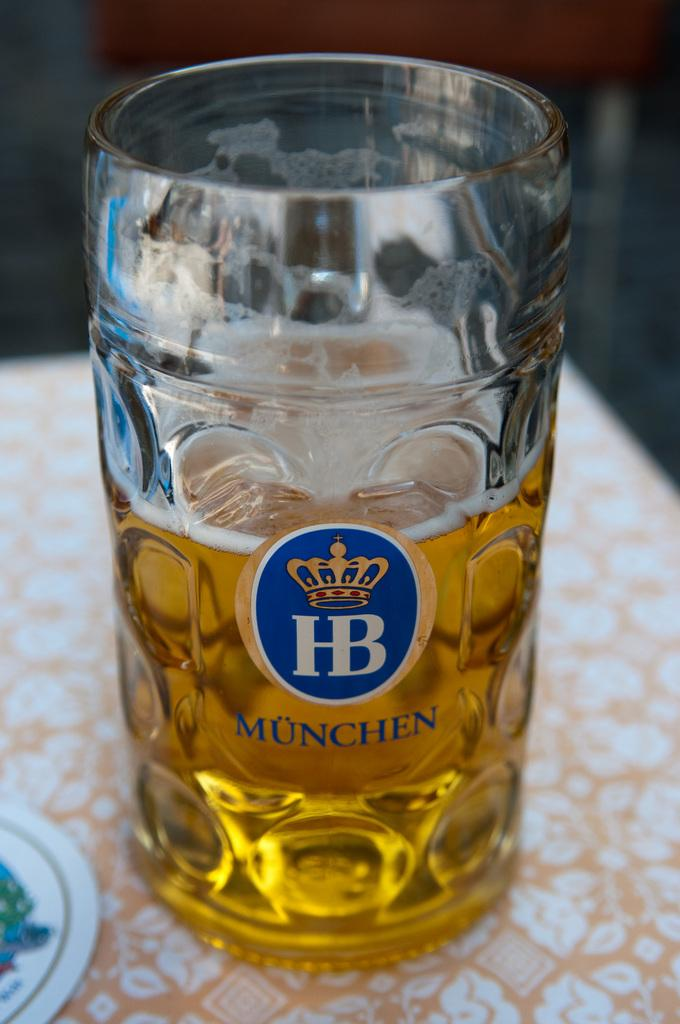What is in the glass that is visible in the image? There is a glass of beer in the image. Where is the glass of beer located? The glass of beer is placed on a table. What type of shoe is visible in the image? There is no shoe present in the image. Is there a tub filled with water in the image? There is no tub filled with water present in the image. 